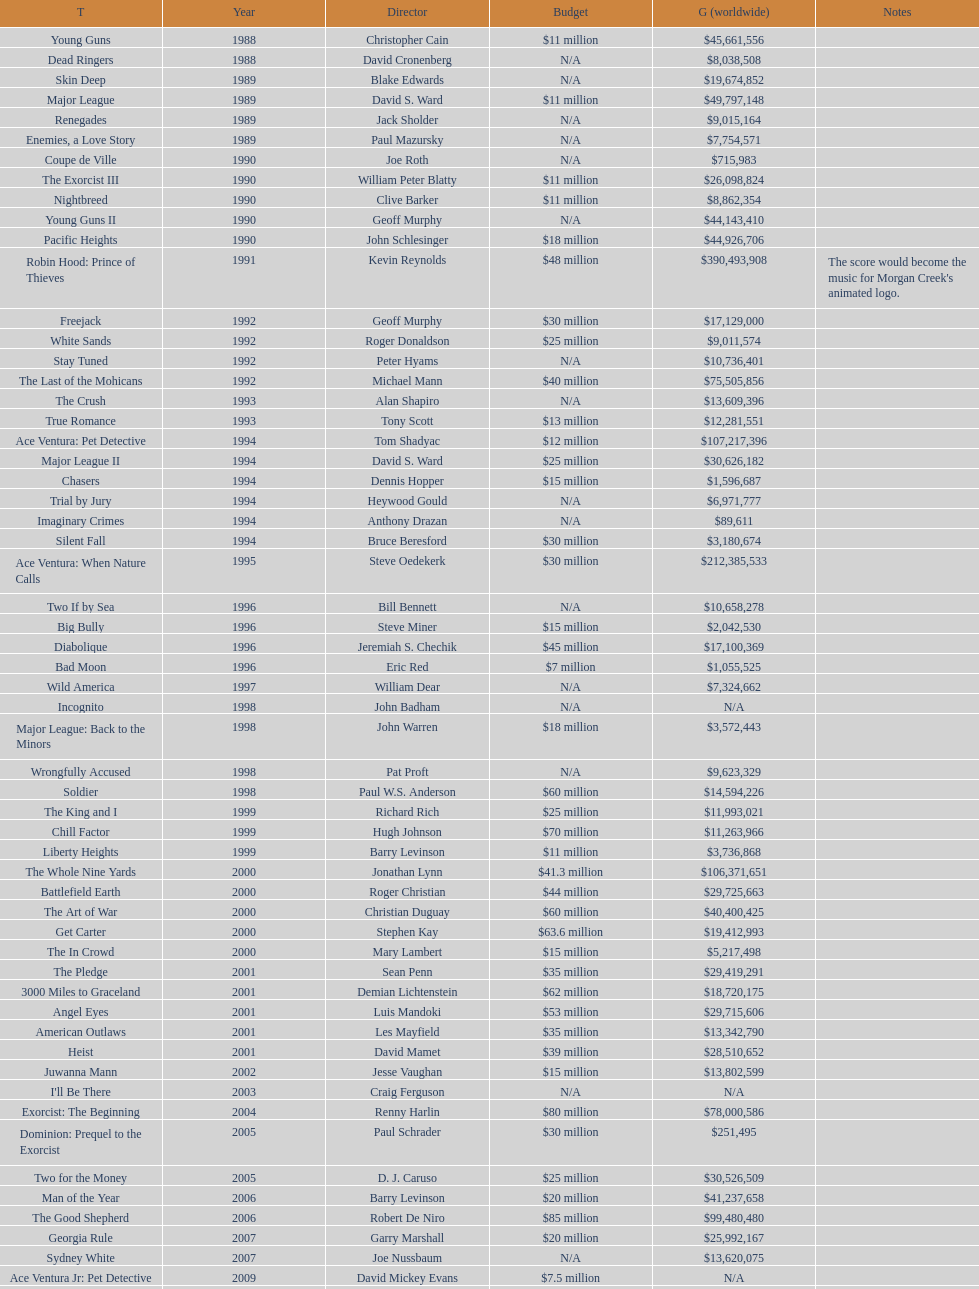Help me parse the entirety of this table. {'header': ['T', 'Year', 'Director', 'Budget', 'G (worldwide)', 'Notes'], 'rows': [['Young Guns', '1988', 'Christopher Cain', '$11 million', '$45,661,556', ''], ['Dead Ringers', '1988', 'David Cronenberg', 'N/A', '$8,038,508', ''], ['Skin Deep', '1989', 'Blake Edwards', 'N/A', '$19,674,852', ''], ['Major League', '1989', 'David S. Ward', '$11 million', '$49,797,148', ''], ['Renegades', '1989', 'Jack Sholder', 'N/A', '$9,015,164', ''], ['Enemies, a Love Story', '1989', 'Paul Mazursky', 'N/A', '$7,754,571', ''], ['Coupe de Ville', '1990', 'Joe Roth', 'N/A', '$715,983', ''], ['The Exorcist III', '1990', 'William Peter Blatty', '$11 million', '$26,098,824', ''], ['Nightbreed', '1990', 'Clive Barker', '$11 million', '$8,862,354', ''], ['Young Guns II', '1990', 'Geoff Murphy', 'N/A', '$44,143,410', ''], ['Pacific Heights', '1990', 'John Schlesinger', '$18 million', '$44,926,706', ''], ['Robin Hood: Prince of Thieves', '1991', 'Kevin Reynolds', '$48 million', '$390,493,908', "The score would become the music for Morgan Creek's animated logo."], ['Freejack', '1992', 'Geoff Murphy', '$30 million', '$17,129,000', ''], ['White Sands', '1992', 'Roger Donaldson', '$25 million', '$9,011,574', ''], ['Stay Tuned', '1992', 'Peter Hyams', 'N/A', '$10,736,401', ''], ['The Last of the Mohicans', '1992', 'Michael Mann', '$40 million', '$75,505,856', ''], ['The Crush', '1993', 'Alan Shapiro', 'N/A', '$13,609,396', ''], ['True Romance', '1993', 'Tony Scott', '$13 million', '$12,281,551', ''], ['Ace Ventura: Pet Detective', '1994', 'Tom Shadyac', '$12 million', '$107,217,396', ''], ['Major League II', '1994', 'David S. Ward', '$25 million', '$30,626,182', ''], ['Chasers', '1994', 'Dennis Hopper', '$15 million', '$1,596,687', ''], ['Trial by Jury', '1994', 'Heywood Gould', 'N/A', '$6,971,777', ''], ['Imaginary Crimes', '1994', 'Anthony Drazan', 'N/A', '$89,611', ''], ['Silent Fall', '1994', 'Bruce Beresford', '$30 million', '$3,180,674', ''], ['Ace Ventura: When Nature Calls', '1995', 'Steve Oedekerk', '$30 million', '$212,385,533', ''], ['Two If by Sea', '1996', 'Bill Bennett', 'N/A', '$10,658,278', ''], ['Big Bully', '1996', 'Steve Miner', '$15 million', '$2,042,530', ''], ['Diabolique', '1996', 'Jeremiah S. Chechik', '$45 million', '$17,100,369', ''], ['Bad Moon', '1996', 'Eric Red', '$7 million', '$1,055,525', ''], ['Wild America', '1997', 'William Dear', 'N/A', '$7,324,662', ''], ['Incognito', '1998', 'John Badham', 'N/A', 'N/A', ''], ['Major League: Back to the Minors', '1998', 'John Warren', '$18 million', '$3,572,443', ''], ['Wrongfully Accused', '1998', 'Pat Proft', 'N/A', '$9,623,329', ''], ['Soldier', '1998', 'Paul W.S. Anderson', '$60 million', '$14,594,226', ''], ['The King and I', '1999', 'Richard Rich', '$25 million', '$11,993,021', ''], ['Chill Factor', '1999', 'Hugh Johnson', '$70 million', '$11,263,966', ''], ['Liberty Heights', '1999', 'Barry Levinson', '$11 million', '$3,736,868', ''], ['The Whole Nine Yards', '2000', 'Jonathan Lynn', '$41.3 million', '$106,371,651', ''], ['Battlefield Earth', '2000', 'Roger Christian', '$44 million', '$29,725,663', ''], ['The Art of War', '2000', 'Christian Duguay', '$60 million', '$40,400,425', ''], ['Get Carter', '2000', 'Stephen Kay', '$63.6 million', '$19,412,993', ''], ['The In Crowd', '2000', 'Mary Lambert', '$15 million', '$5,217,498', ''], ['The Pledge', '2001', 'Sean Penn', '$35 million', '$29,419,291', ''], ['3000 Miles to Graceland', '2001', 'Demian Lichtenstein', '$62 million', '$18,720,175', ''], ['Angel Eyes', '2001', 'Luis Mandoki', '$53 million', '$29,715,606', ''], ['American Outlaws', '2001', 'Les Mayfield', '$35 million', '$13,342,790', ''], ['Heist', '2001', 'David Mamet', '$39 million', '$28,510,652', ''], ['Juwanna Mann', '2002', 'Jesse Vaughan', '$15 million', '$13,802,599', ''], ["I'll Be There", '2003', 'Craig Ferguson', 'N/A', 'N/A', ''], ['Exorcist: The Beginning', '2004', 'Renny Harlin', '$80 million', '$78,000,586', ''], ['Dominion: Prequel to the Exorcist', '2005', 'Paul Schrader', '$30 million', '$251,495', ''], ['Two for the Money', '2005', 'D. J. Caruso', '$25 million', '$30,526,509', ''], ['Man of the Year', '2006', 'Barry Levinson', '$20 million', '$41,237,658', ''], ['The Good Shepherd', '2006', 'Robert De Niro', '$85 million', '$99,480,480', ''], ['Georgia Rule', '2007', 'Garry Marshall', '$20 million', '$25,992,167', ''], ['Sydney White', '2007', 'Joe Nussbaum', 'N/A', '$13,620,075', ''], ['Ace Ventura Jr: Pet Detective', '2009', 'David Mickey Evans', '$7.5 million', 'N/A', ''], ['Dream House', '2011', 'Jim Sheridan', '$50 million', '$38,502,340', ''], ['The Thing', '2011', 'Matthijs van Heijningen Jr.', '$38 million', '$27,428,670', ''], ['Tupac', '2014', 'Antoine Fuqua', '$45 million', '', '']]} In 1990, what was the total number of movies released? 5. 